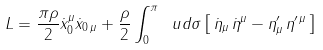<formula> <loc_0><loc_0><loc_500><loc_500>L = \frac { \pi \rho } { 2 } \dot { x } ^ { \mu } _ { 0 } \dot { x } _ { 0 \, \mu } + \frac { \rho } { 2 } \int _ { 0 } ^ { \pi } \ u d \sigma \left [ \, \dot { \eta } _ { \mu } \, \dot { \eta } ^ { \mu } - { \eta } ^ { \prime } _ { \mu } \, { \eta } ^ { \prime \, \mu } \, \right ]</formula> 